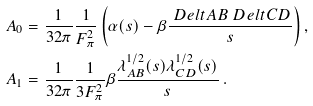<formula> <loc_0><loc_0><loc_500><loc_500>A _ { 0 } & = \frac { 1 } { 3 2 \pi } \frac { 1 } { F _ { \pi } ^ { 2 } } \left ( \alpha ( s ) - \beta \frac { \ D e l t { A B } \ D e l t { C D } } { s } \right ) , \\ A _ { 1 } & = \frac { 1 } { 3 2 \pi } \frac { 1 } { 3 F _ { \pi } ^ { 2 } } \beta \frac { \lambda ^ { 1 / 2 } _ { A B } ( s ) \lambda ^ { 1 / 2 } _ { C D } ( s ) } { s } \, .</formula> 